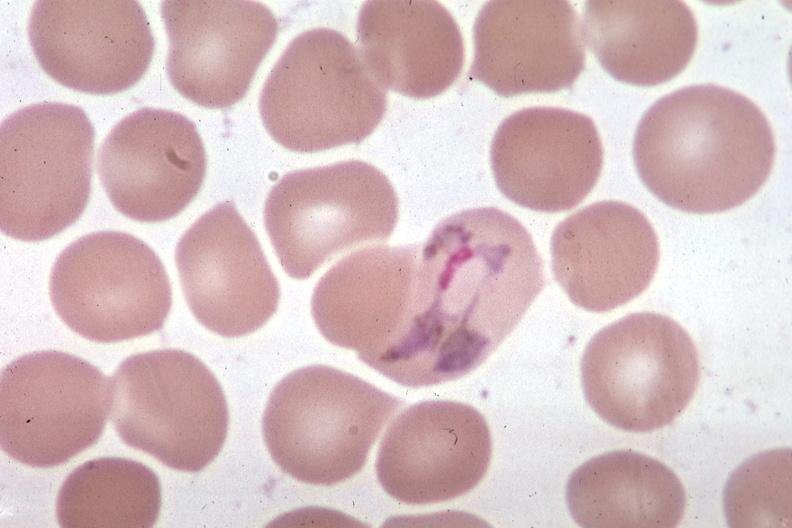what is present?
Answer the question using a single word or phrase. Hematologic 